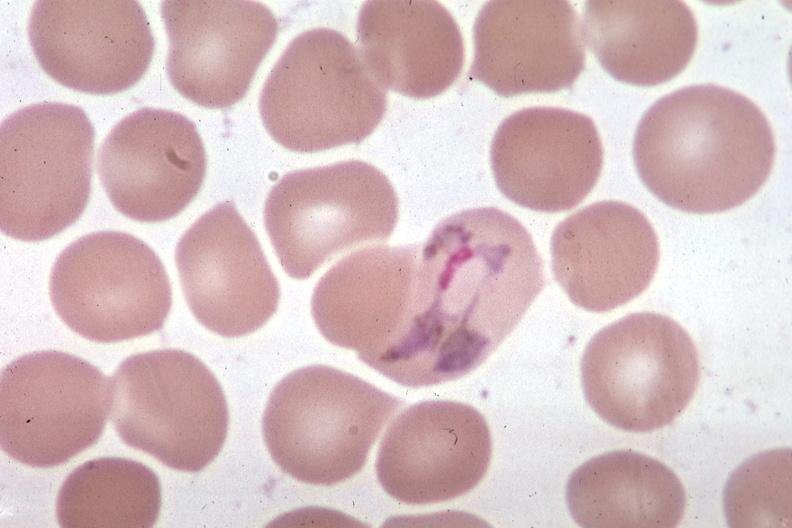what is present?
Answer the question using a single word or phrase. Hematologic 